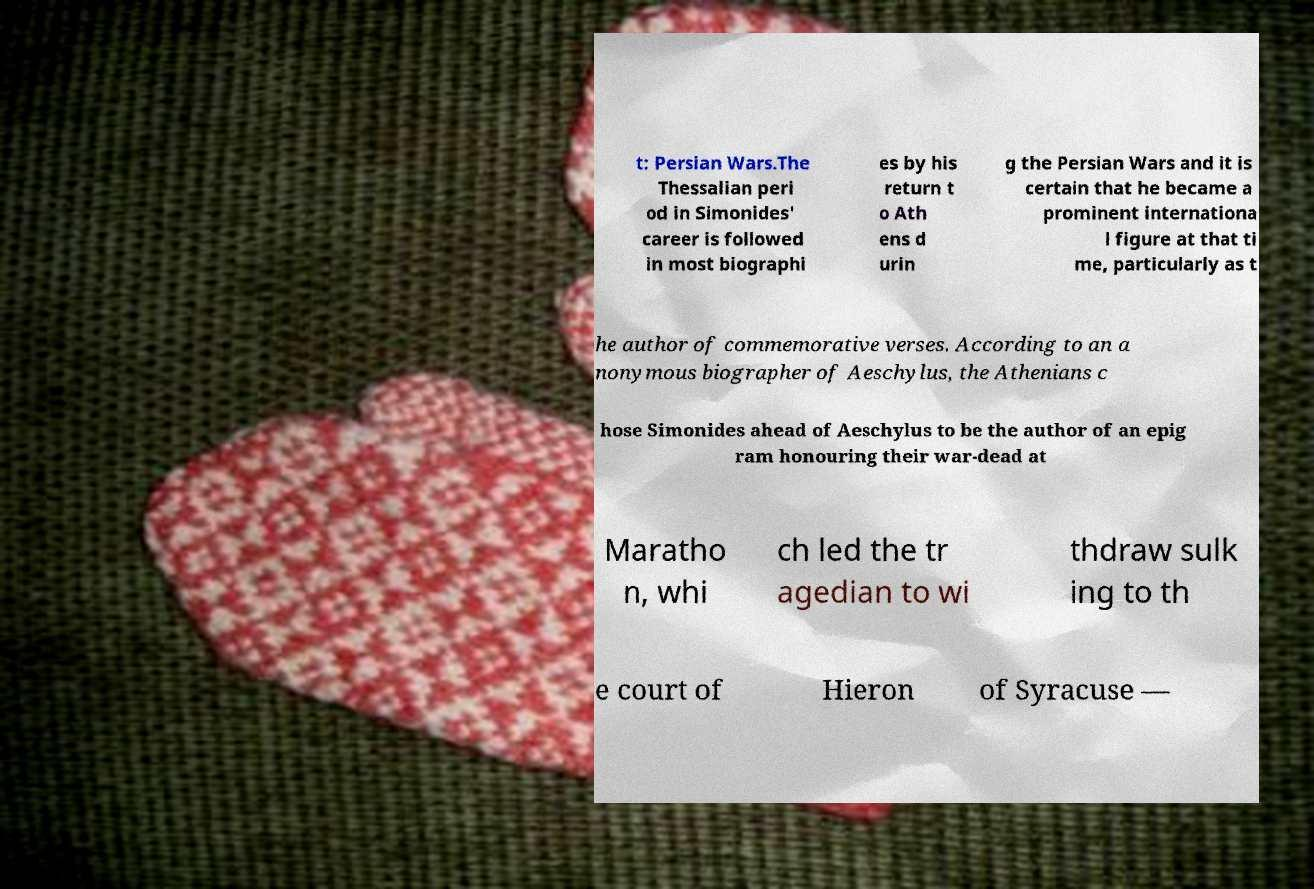For documentation purposes, I need the text within this image transcribed. Could you provide that? t: Persian Wars.The Thessalian peri od in Simonides' career is followed in most biographi es by his return t o Ath ens d urin g the Persian Wars and it is certain that he became a prominent internationa l figure at that ti me, particularly as t he author of commemorative verses. According to an a nonymous biographer of Aeschylus, the Athenians c hose Simonides ahead of Aeschylus to be the author of an epig ram honouring their war-dead at Maratho n, whi ch led the tr agedian to wi thdraw sulk ing to th e court of Hieron of Syracuse — 